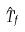Convert formula to latex. <formula><loc_0><loc_0><loc_500><loc_500>\hat { T } _ { f }</formula> 